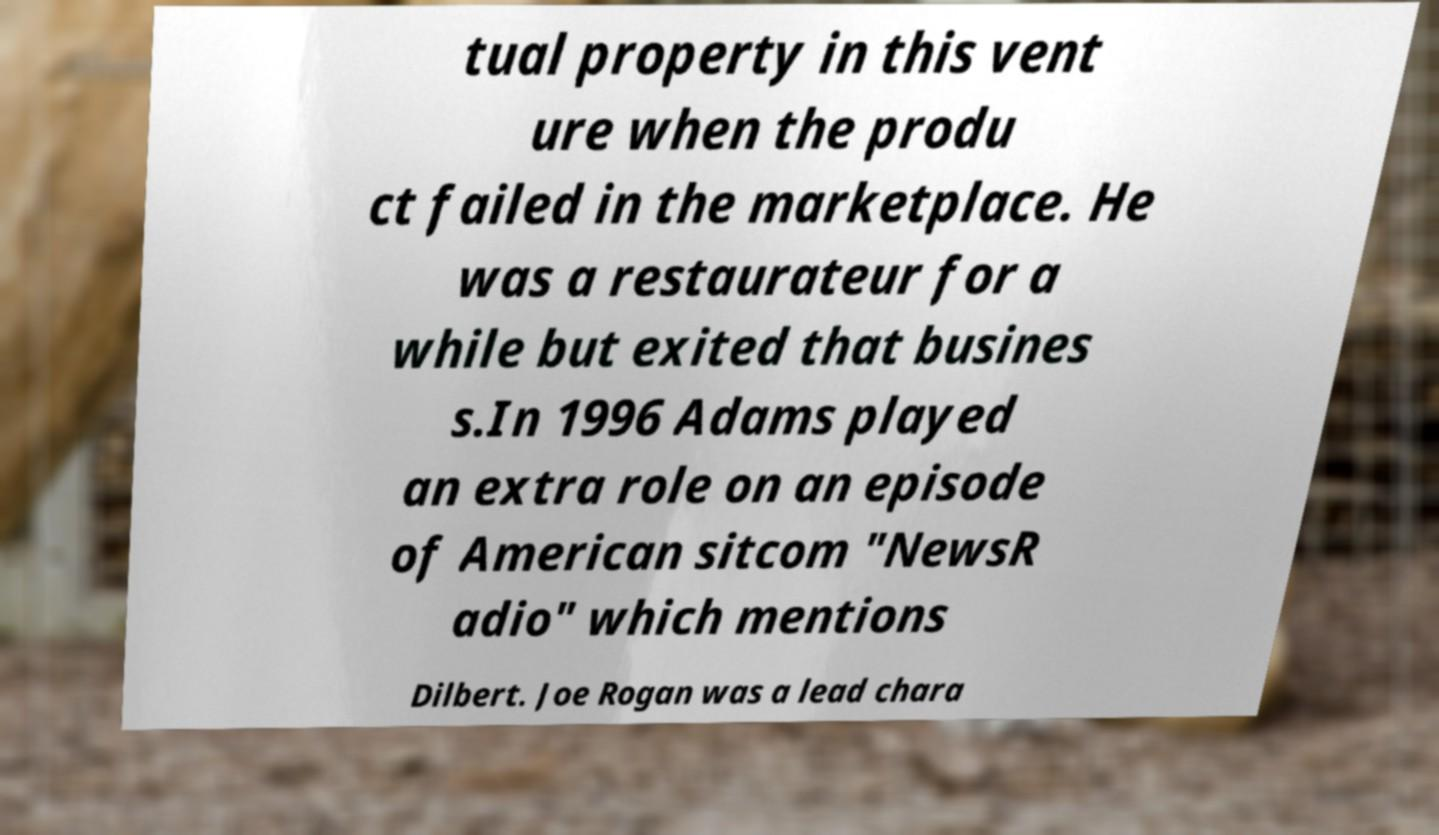Can you accurately transcribe the text from the provided image for me? tual property in this vent ure when the produ ct failed in the marketplace. He was a restaurateur for a while but exited that busines s.In 1996 Adams played an extra role on an episode of American sitcom "NewsR adio" which mentions Dilbert. Joe Rogan was a lead chara 